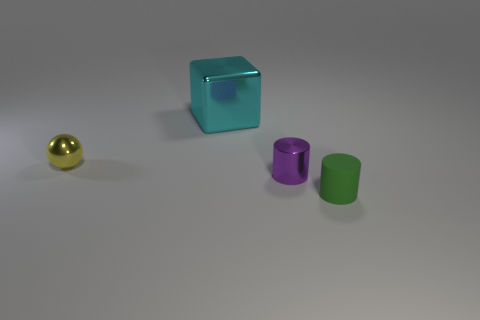If these objects were part of a set, what other items might you expect to find with them? Given their simple geometric shapes and uniform materials, these objects might be part of a designer decor set. You might expect to find other items such as a matching tray, coasters, or even minimalist vases in the same style and color scheme. 